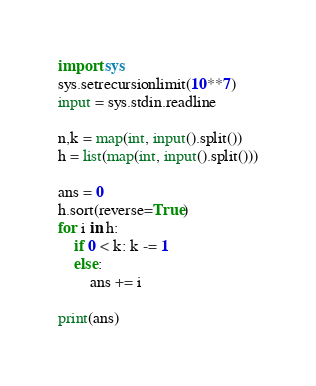<code> <loc_0><loc_0><loc_500><loc_500><_Python_>import sys
sys.setrecursionlimit(10**7)
input = sys.stdin.readline

n,k = map(int, input().split())
h = list(map(int, input().split()))

ans = 0
h.sort(reverse=True)
for i in h:
    if 0 < k: k -= 1
    else:
        ans += i

print(ans)
</code> 